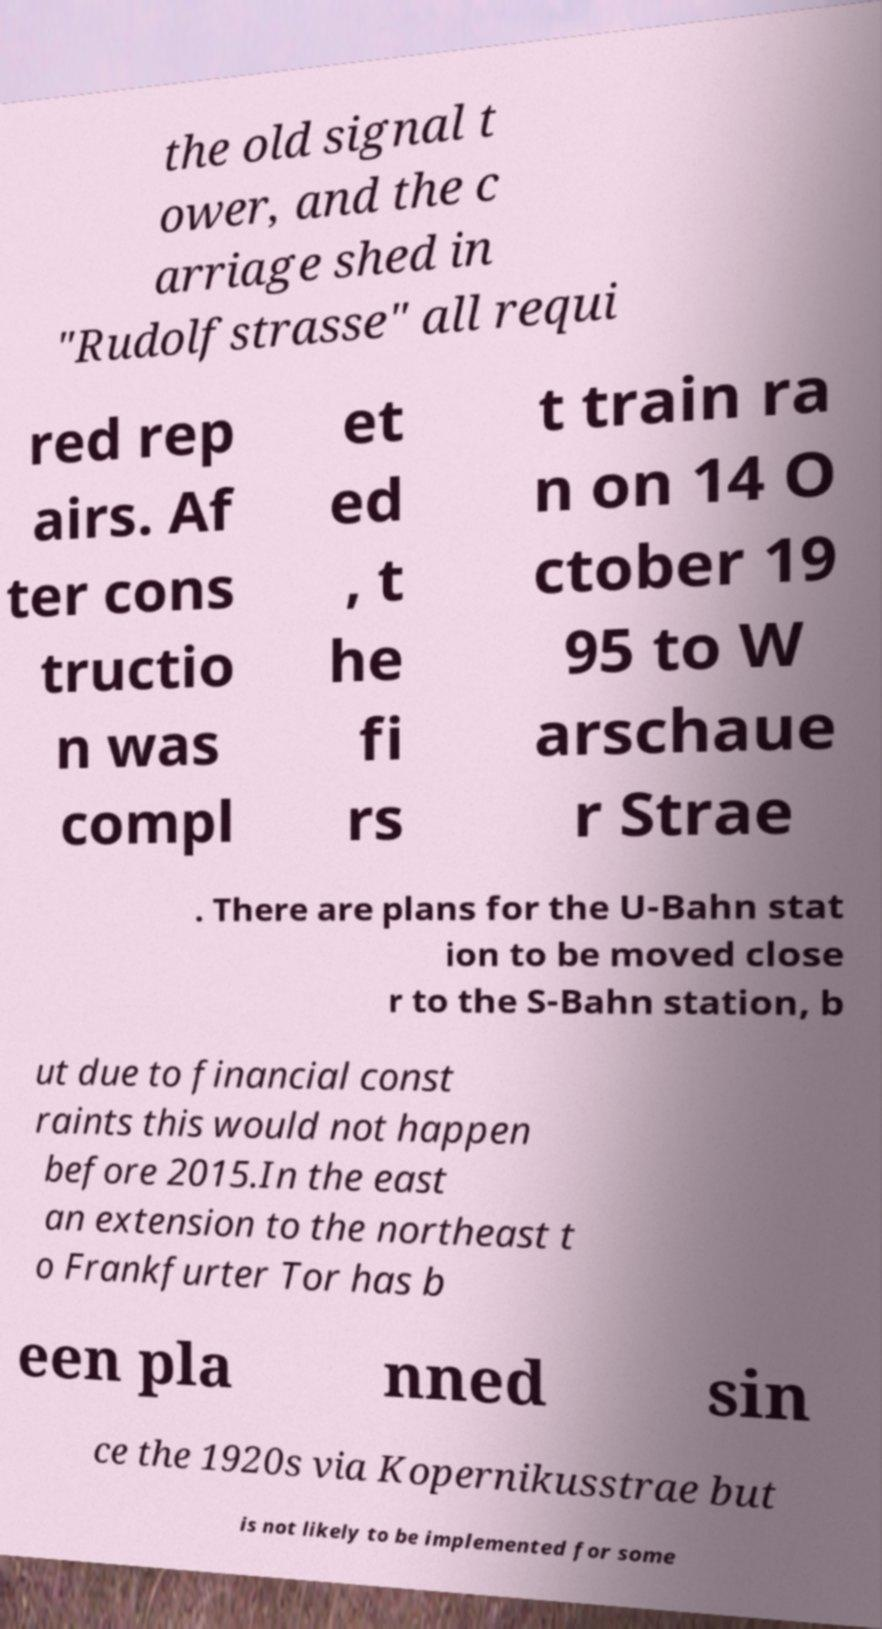What messages or text are displayed in this image? I need them in a readable, typed format. the old signal t ower, and the c arriage shed in "Rudolfstrasse" all requi red rep airs. Af ter cons tructio n was compl et ed , t he fi rs t train ra n on 14 O ctober 19 95 to W arschaue r Strae . There are plans for the U-Bahn stat ion to be moved close r to the S-Bahn station, b ut due to financial const raints this would not happen before 2015.In the east an extension to the northeast t o Frankfurter Tor has b een pla nned sin ce the 1920s via Kopernikusstrae but is not likely to be implemented for some 